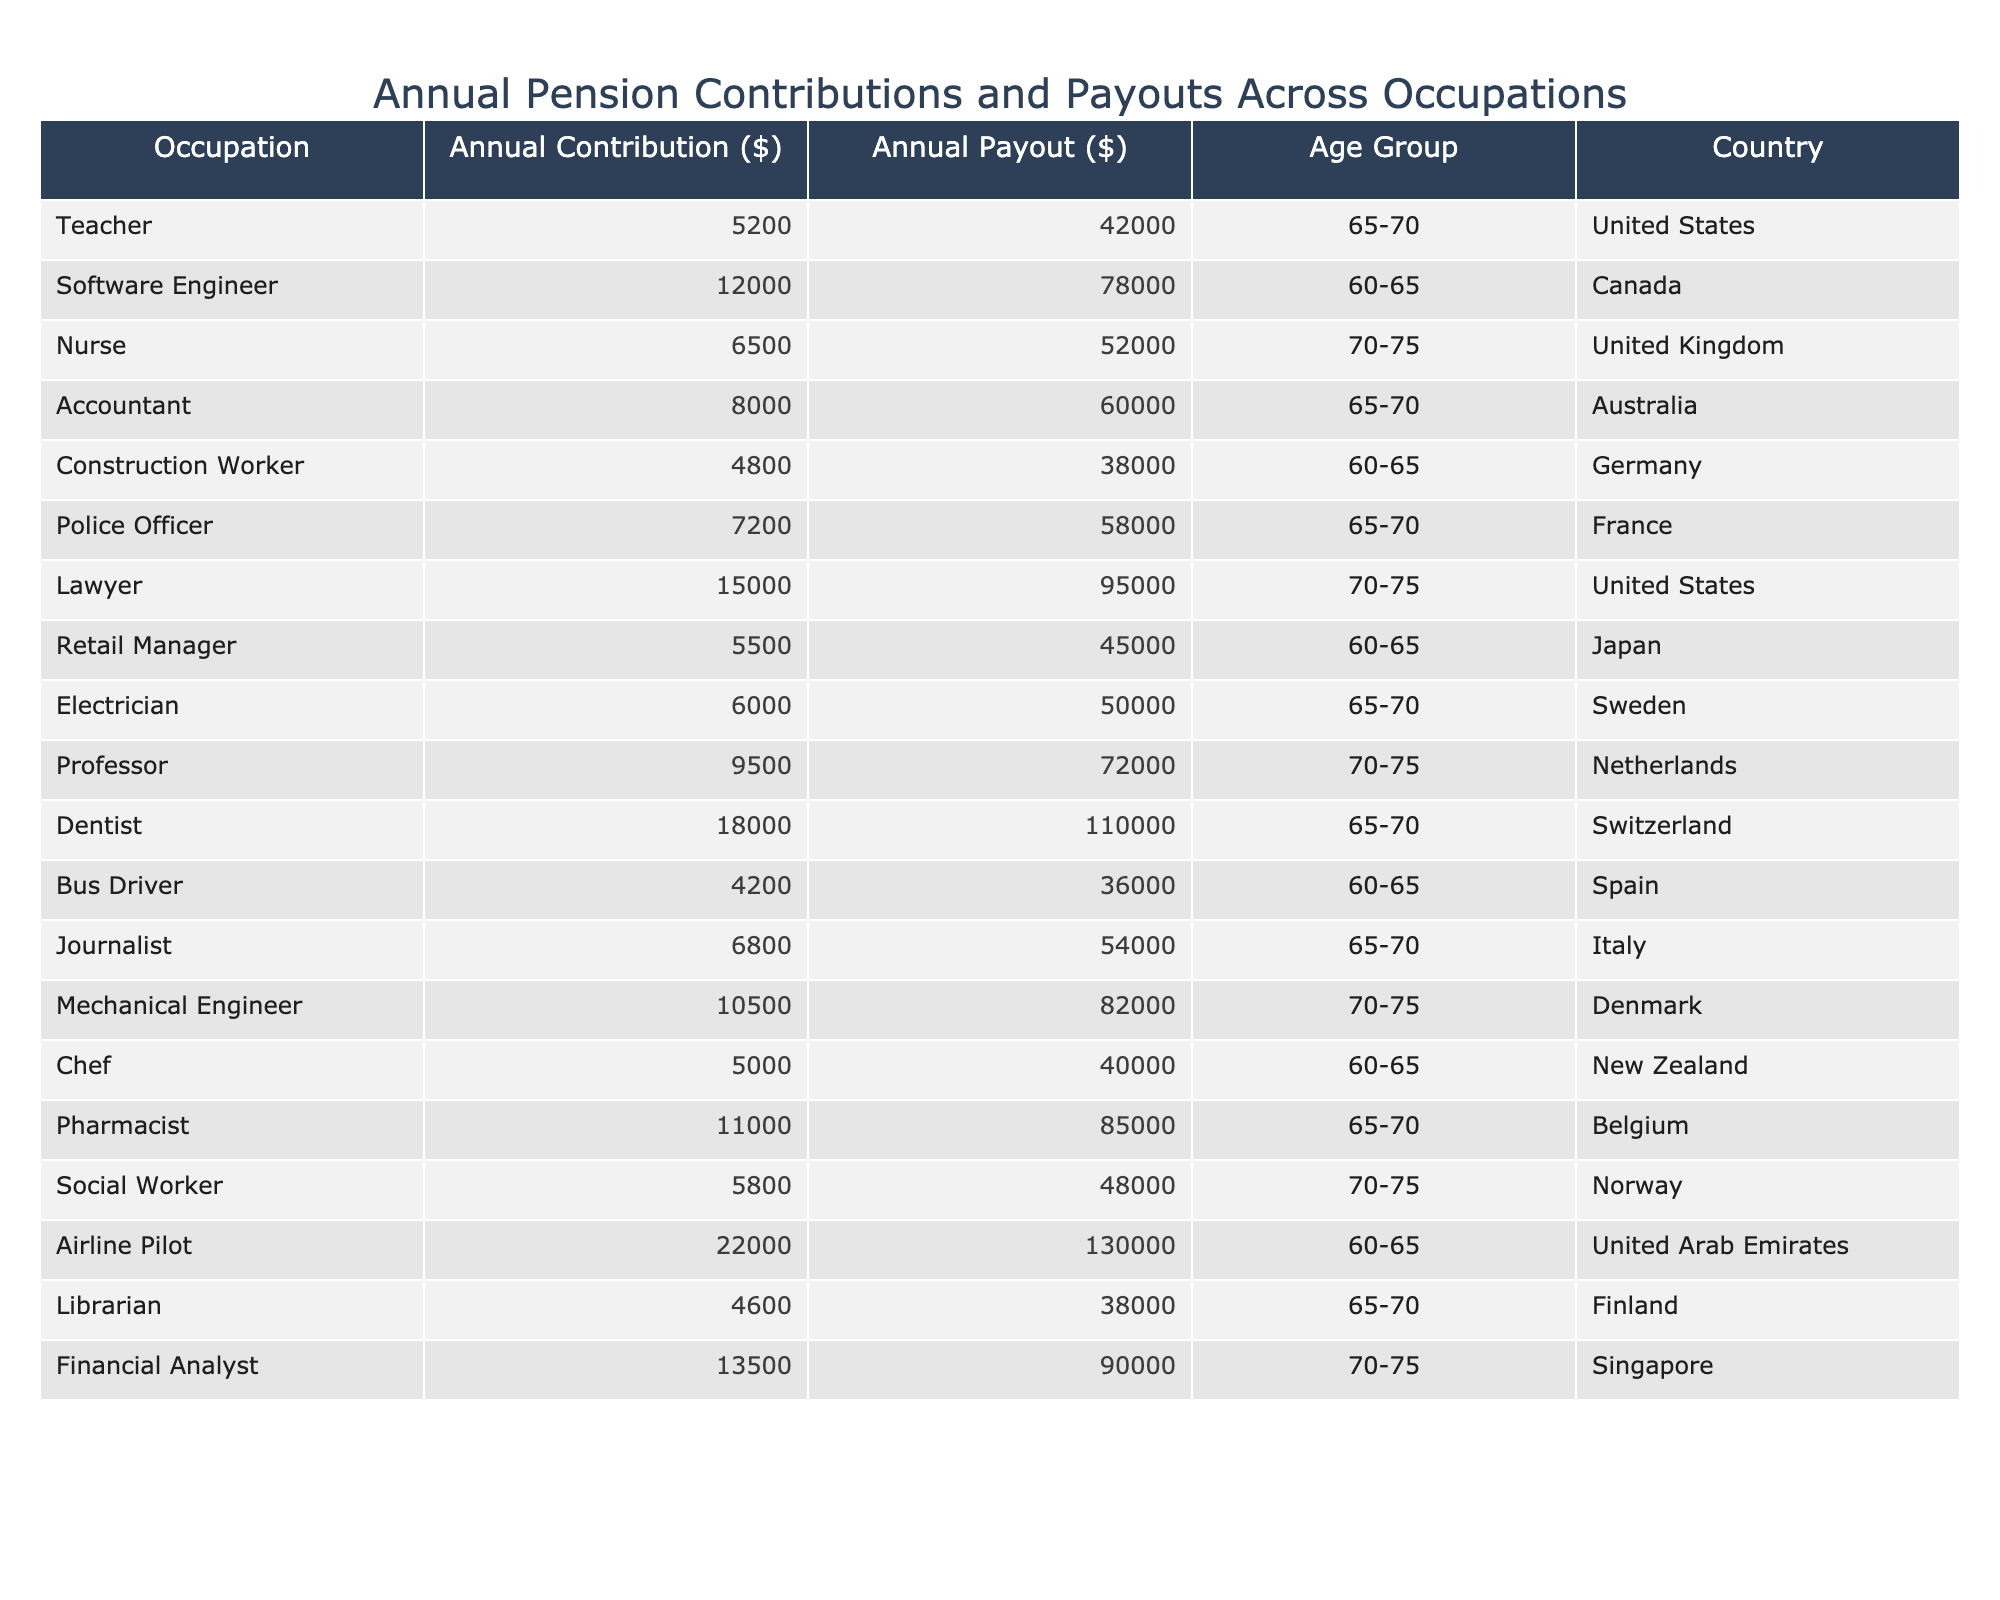What is the annual contribution of a dentist? From the table, the annual contribution for a dentist is directly listed as $18,000.
Answer: 18,000 Which occupation has the highest annual payout? By reviewing the payout column, the occupation with the highest payout is a dentist with an annual payout of $110,000.
Answer: Dentist What is the average annual contribution of the healthcare-related occupations (nurse, pharmacist, and social worker)? The contributions of the nurse ($6,500), pharmacist ($11,000), and social worker ($5,800) are summed to get $6,500 + $11,000 + $5,800 = $23,300. Since there are 3 occupations, the average is $23,300 / 3 = $7,766.67.
Answer: 7,766.67 Is the annual contribution of an airline pilot higher than that of a police officer? The annual contribution for an airline pilot is $22,000, while for a police officer it is $7,200. Since $22,000 is greater than $7,200, the statement is true.
Answer: Yes What is the total annual payout for occupations in the age group 60-65? The annual payouts for the 60-65 age group (Software Engineer: $78,000, Construction Worker: $38,000, Retail Manager: $45,000, Bus Driver: $36,000, Chef: $40,000) add up to $78,000 + $38,000 + $45,000 + $36,000 + $40,000 = $237,000.
Answer: 237,000 Which country has the highest average pension payout for the age group 65-70? For the age group 65-70, the payouts by country are as follows: US ($42,000), Australia ($60,000), France ($58,000), UK ($52,000), Sweden ($50,000), Belgium ($85,000). The average is calculated by finding the highest among these, which is Belgium with $85,000.
Answer: Belgium What is the difference in annual contribution between the lowest and highest contributors in this dataset? The lowest annual contribution is $4,200 (Bus Driver) and the highest is $22,000 (Airline Pilot). The difference is $22,000 - $4,200 = $17,800.
Answer: 17,800 Which occupation has an annual payout that is less than its annual contribution? From the table, the only occupation where the payout is less than the contribution is the Teacher (Annual Contribution: $5,200, Annual Payout: $42,000). Comparing these, it is clear the payout exceeds the contribution, thus no occupation fits this criterion.
Answer: None 